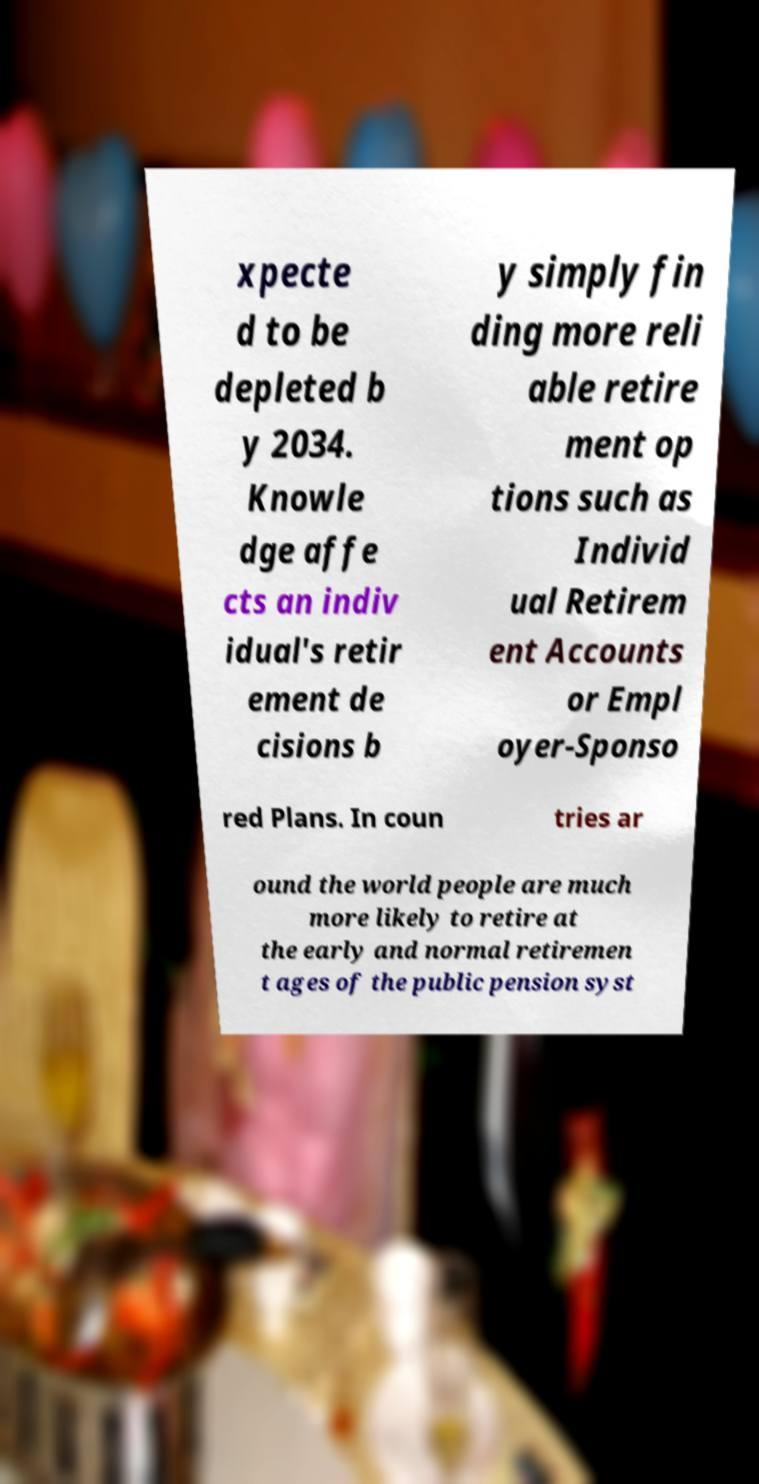Please identify and transcribe the text found in this image. xpecte d to be depleted b y 2034. Knowle dge affe cts an indiv idual's retir ement de cisions b y simply fin ding more reli able retire ment op tions such as Individ ual Retirem ent Accounts or Empl oyer-Sponso red Plans. In coun tries ar ound the world people are much more likely to retire at the early and normal retiremen t ages of the public pension syst 